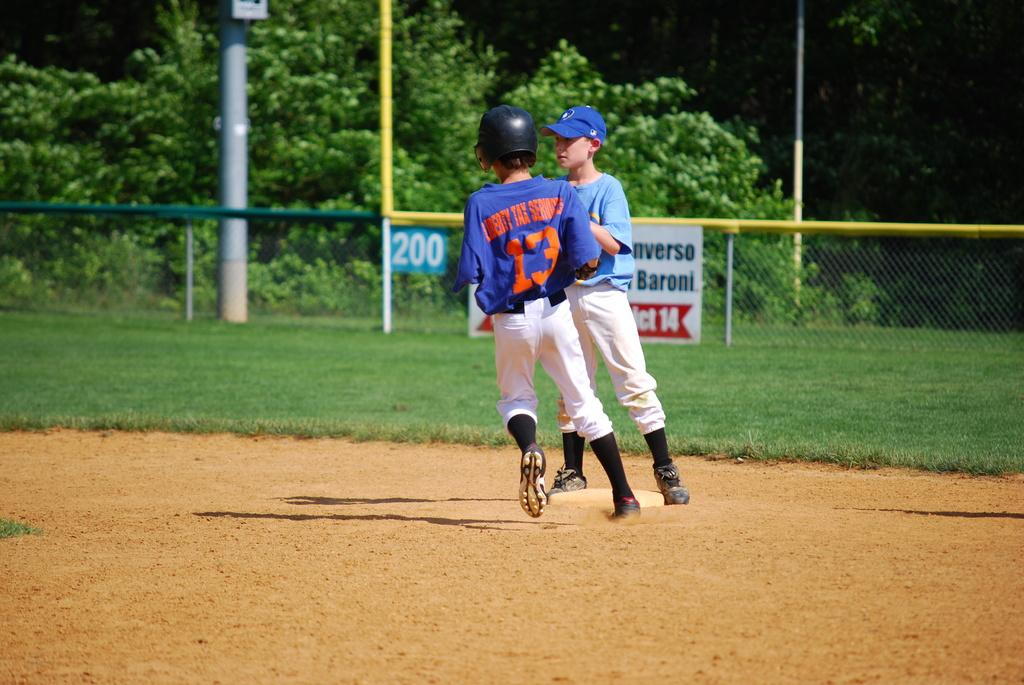<image>
Offer a succinct explanation of the picture presented. A child with the number 13 on his back running past a child standing 